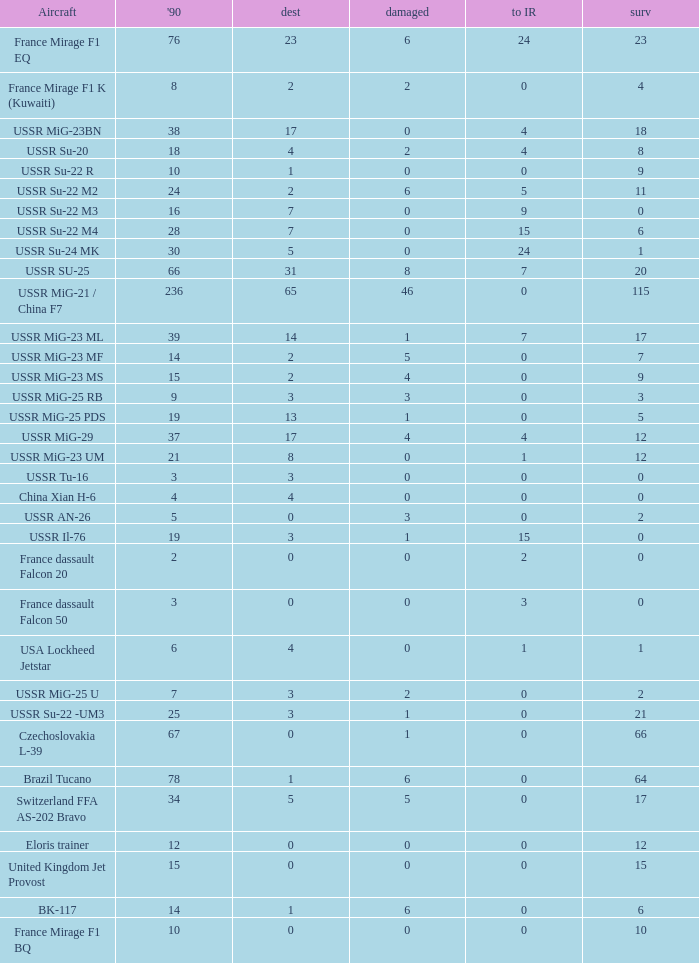If the aircraft was  ussr mig-25 rb how many were destroyed? 3.0. 